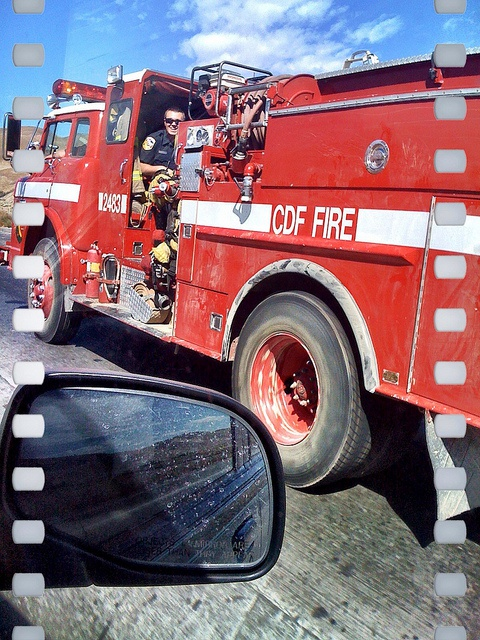Describe the objects in this image and their specific colors. I can see truck in gray, salmon, lightgray, red, and black tones and people in gray, black, navy, and white tones in this image. 